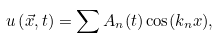Convert formula to latex. <formula><loc_0><loc_0><loc_500><loc_500>u \left ( \vec { x } , t \right ) = \sum A _ { n } ( t ) \cos ( k _ { n } x ) ,</formula> 